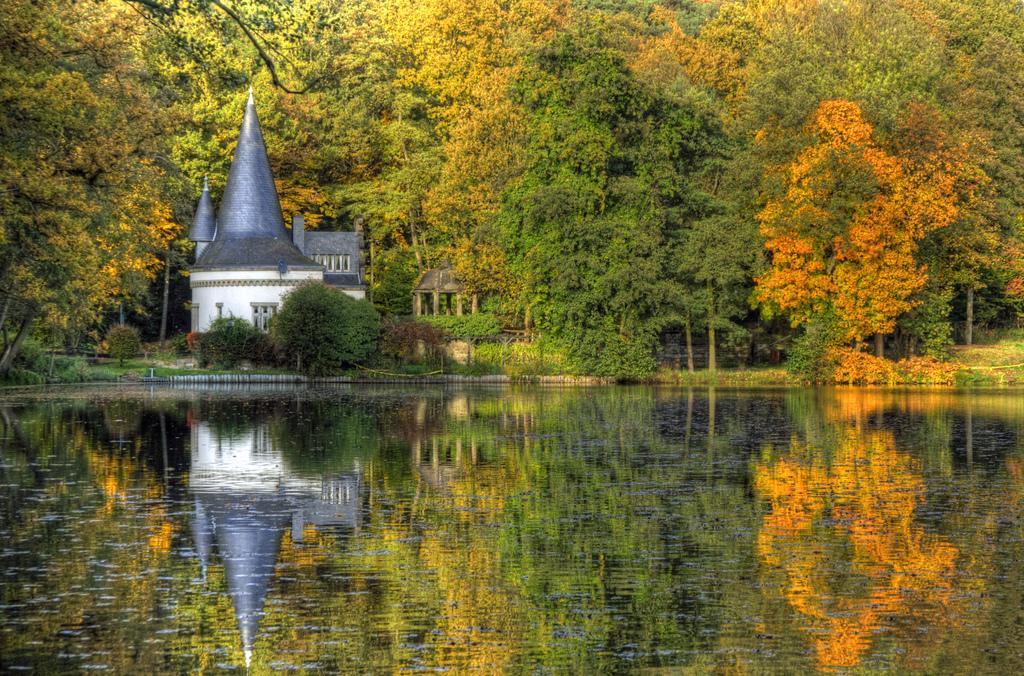Could you give a brief overview of what you see in this image? In this image I can see the house which is in white and blue color. To the side of the house I can see many trees which are in green, orange and yellow color. In-front of the trees I can see the water. 